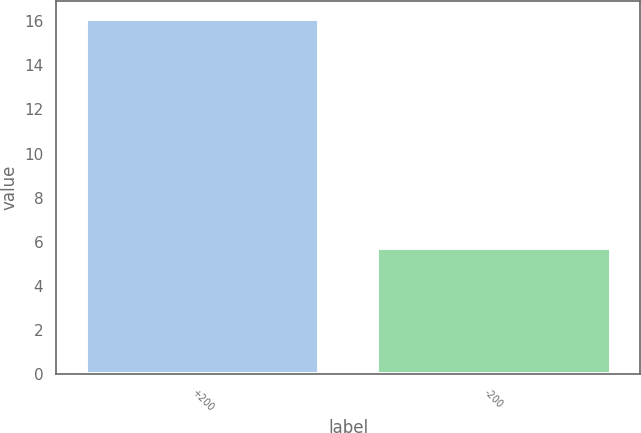<chart> <loc_0><loc_0><loc_500><loc_500><bar_chart><fcel>+200<fcel>-200<nl><fcel>16.1<fcel>5.7<nl></chart> 